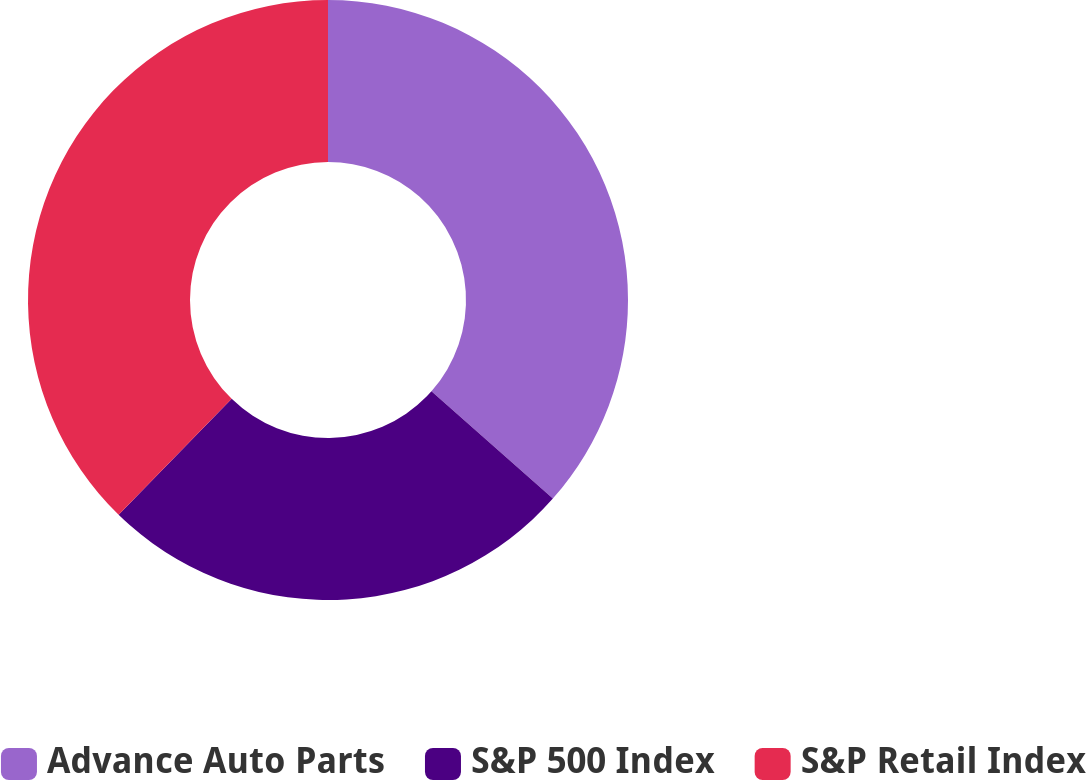Convert chart. <chart><loc_0><loc_0><loc_500><loc_500><pie_chart><fcel>Advance Auto Parts<fcel>S&P 500 Index<fcel>S&P Retail Index<nl><fcel>36.51%<fcel>25.78%<fcel>37.7%<nl></chart> 